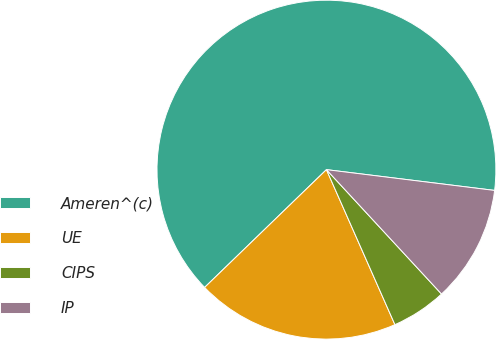<chart> <loc_0><loc_0><loc_500><loc_500><pie_chart><fcel>Ameren^(c)<fcel>UE<fcel>CIPS<fcel>IP<nl><fcel>64.19%<fcel>19.39%<fcel>5.26%<fcel>11.16%<nl></chart> 